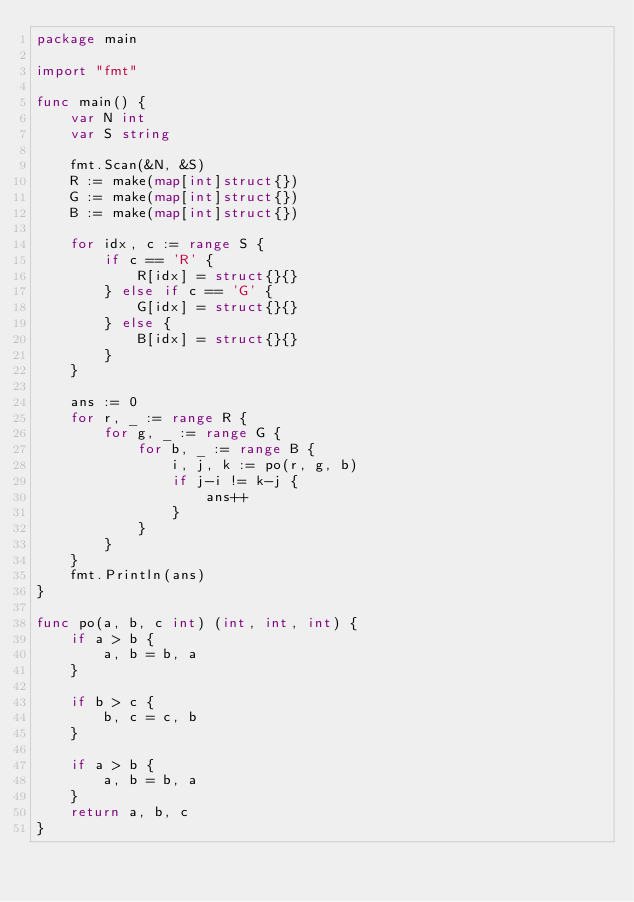Convert code to text. <code><loc_0><loc_0><loc_500><loc_500><_Go_>package main

import "fmt"

func main() {
	var N int
	var S string

	fmt.Scan(&N, &S)
	R := make(map[int]struct{})
	G := make(map[int]struct{})
	B := make(map[int]struct{})

	for idx, c := range S {
		if c == 'R' {
			R[idx] = struct{}{}
		} else if c == 'G' {
			G[idx] = struct{}{}
		} else {
			B[idx] = struct{}{}
		}
	}

	ans := 0
	for r, _ := range R {
		for g, _ := range G {
			for b, _ := range B {
				i, j, k := po(r, g, b)
				if j-i != k-j {
					ans++
				}
			}
		}
	}
	fmt.Println(ans)
}

func po(a, b, c int) (int, int, int) {
	if a > b {
		a, b = b, a
	}

	if b > c {
		b, c = c, b
	}

	if a > b {
		a, b = b, a
	}
	return a, b, c
}
</code> 